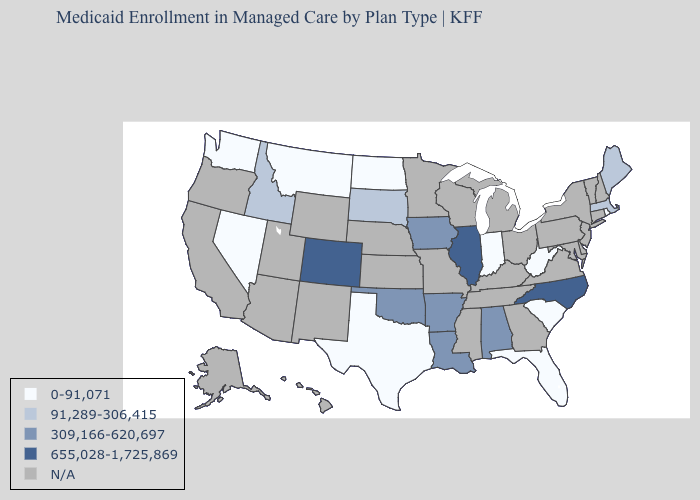What is the value of Georgia?
Quick response, please. N/A. Name the states that have a value in the range 0-91,071?
Answer briefly. Florida, Indiana, Montana, Nevada, North Dakota, Rhode Island, South Carolina, Texas, Washington, West Virginia. Name the states that have a value in the range 0-91,071?
Concise answer only. Florida, Indiana, Montana, Nevada, North Dakota, Rhode Island, South Carolina, Texas, Washington, West Virginia. What is the highest value in the Northeast ?
Give a very brief answer. 91,289-306,415. What is the value of Arkansas?
Concise answer only. 309,166-620,697. Name the states that have a value in the range 309,166-620,697?
Be succinct. Alabama, Arkansas, Iowa, Louisiana, Oklahoma. Among the states that border Tennessee , does Alabama have the highest value?
Quick response, please. No. Name the states that have a value in the range N/A?
Write a very short answer. Alaska, Arizona, California, Connecticut, Delaware, Georgia, Hawaii, Kansas, Kentucky, Maryland, Michigan, Minnesota, Mississippi, Missouri, Nebraska, New Hampshire, New Jersey, New Mexico, New York, Ohio, Oregon, Pennsylvania, Tennessee, Utah, Vermont, Virginia, Wisconsin, Wyoming. What is the value of California?
Quick response, please. N/A. What is the value of Virginia?
Concise answer only. N/A. Among the states that border Illinois , does Indiana have the lowest value?
Short answer required. Yes. What is the value of Nevada?
Give a very brief answer. 0-91,071. 